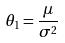<formula> <loc_0><loc_0><loc_500><loc_500>\theta _ { 1 } = \frac { \mu } { \sigma ^ { 2 } }</formula> 